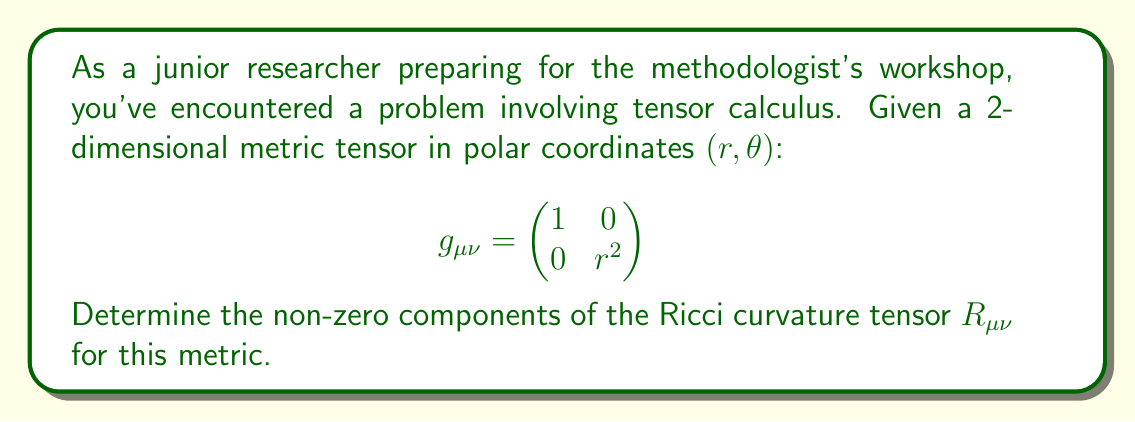Can you answer this question? To find the Ricci curvature tensor, we'll follow these steps:

1) First, calculate the Christoffel symbols $\Gamma^\lambda_{\mu\nu}$ using:

   $$ \Gamma^\lambda_{\mu\nu} = \frac{1}{2}g^{\lambda\sigma}(\partial_\mu g_{\nu\sigma} + \partial_\nu g_{\mu\sigma} - \partial_\sigma g_{\mu\nu}) $$

2) The non-zero Christoffel symbols are:
   
   $\Gamma^r_{\theta\theta} = -r$
   $\Gamma^\theta_{r\theta} = \Gamma^\theta_{\theta r} = \frac{1}{r}$

3) Next, calculate the Riemann curvature tensor $R^\rho_{\sigma\mu\nu}$ using:

   $$ R^\rho_{\sigma\mu\nu} = \partial_\mu\Gamma^\rho_{\nu\sigma} - \partial_\nu\Gamma^\rho_{\mu\sigma} + \Gamma^\rho_{\mu\lambda}\Gamma^\lambda_{\nu\sigma} - \Gamma^\rho_{\nu\lambda}\Gamma^\lambda_{\mu\sigma} $$

4) The only non-zero component of the Riemann tensor is:

   $R^r_{\theta r\theta} = -1$

5) The Ricci tensor $R_{\mu\nu}$ is the contraction of the Riemann tensor:

   $$ R_{\mu\nu} = R^\lambda_{\mu\lambda\nu} $$

6) Calculating the non-zero components:

   $R_{rr} = R^\theta_{r\theta r} = 0$
   $R_{\theta\theta} = R^r_{\theta r\theta} = -1$

Therefore, the only non-zero component of the Ricci tensor is $R_{\theta\theta} = -1$.
Answer: $R_{\theta\theta} = -1$, all other components are zero. 